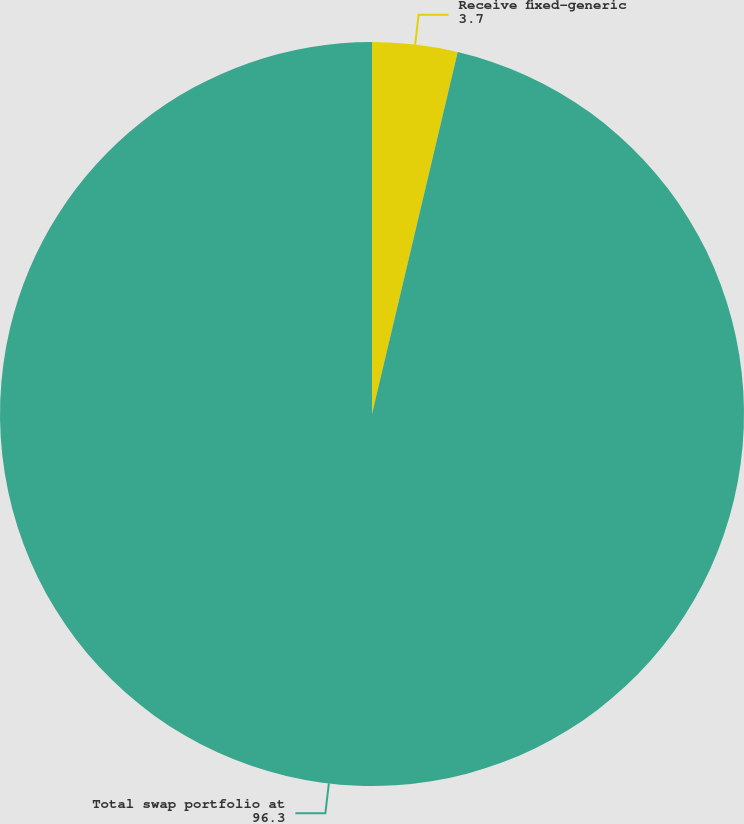Convert chart to OTSL. <chart><loc_0><loc_0><loc_500><loc_500><pie_chart><fcel>Receive fixed-generic<fcel>Total swap portfolio at<nl><fcel>3.7%<fcel>96.3%<nl></chart> 